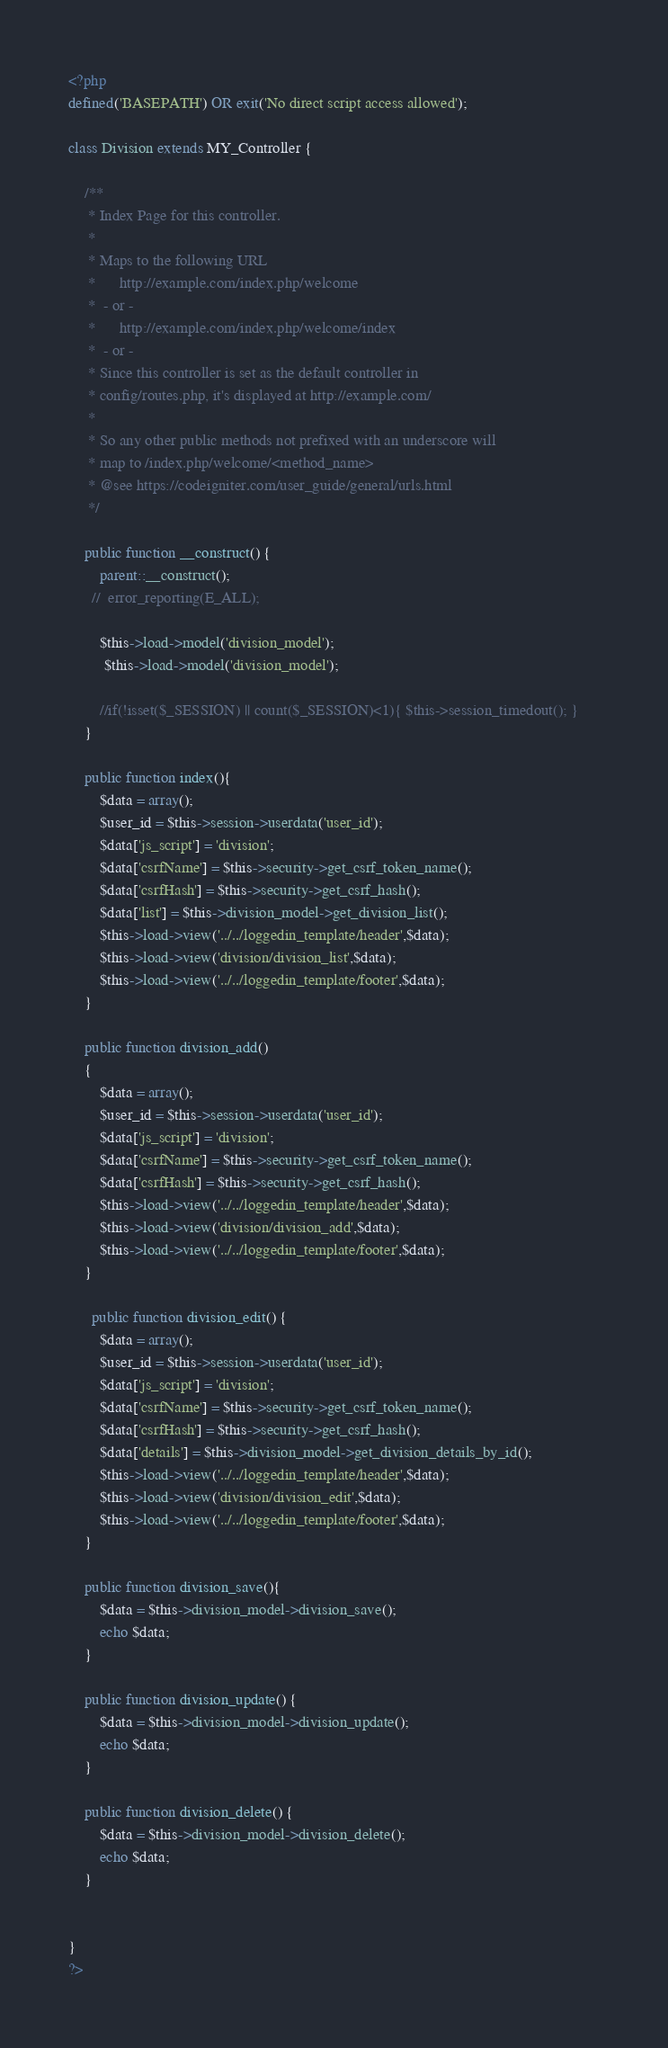Convert code to text. <code><loc_0><loc_0><loc_500><loc_500><_PHP_><?php
defined('BASEPATH') OR exit('No direct script access allowed');

class Division extends MY_Controller {

	/**
	 * Index Page for this controller.
	 *
	 * Maps to the following URL
	 * 		http://example.com/index.php/welcome
	 *	- or -
	 * 		http://example.com/index.php/welcome/index
	 *	- or -
	 * Since this controller is set as the default controller in
	 * config/routes.php, it's displayed at http://example.com/
	 *
	 * So any other public methods not prefixed with an underscore will
	 * map to /index.php/welcome/<method_name>
	 * @see https://codeigniter.com/user_guide/general/urls.html
	 */

    public function __construct() {
        parent::__construct();
      //  error_reporting(E_ALL);
	 
        $this->load->model('division_model');
		 $this->load->model('division_model');
        
        //if(!isset($_SESSION) || count($_SESSION)<1){ $this->session_timedout(); }
    }
	
	public function index(){
		$data = array();
        $user_id = $this->session->userdata('user_id');
        $data['js_script'] = 'division';
        $data['csrfName'] = $this->security->get_csrf_token_name();
        $data['csrfHash'] = $this->security->get_csrf_hash();
        $data['list'] = $this->division_model->get_division_list();
        $this->load->view('../../loggedin_template/header',$data);
        $this->load->view('division/division_list',$data);
        $this->load->view('../../loggedin_template/footer',$data);
	}
	
	public function division_add()
	{
		$data = array();
        $user_id = $this->session->userdata('user_id');
        $data['js_script'] = 'division';
        $data['csrfName'] = $this->security->get_csrf_token_name();
        $data['csrfHash'] = $this->security->get_csrf_hash();	 
        $this->load->view('../../loggedin_template/header',$data);
        $this->load->view('division/division_add',$data);
        $this->load->view('../../loggedin_template/footer',$data);
	}
	
	  public function division_edit() {
        $data = array();
        $user_id = $this->session->userdata('user_id');
        $data['js_script'] = 'division';
        $data['csrfName'] = $this->security->get_csrf_token_name();
        $data['csrfHash'] = $this->security->get_csrf_hash();
        $data['details'] = $this->division_model->get_division_details_by_id();				 
        $this->load->view('../../loggedin_template/header',$data);
        $this->load->view('division/division_edit',$data);
        $this->load->view('../../loggedin_template/footer',$data);
    }
	
	public function division_save(){
		$data = $this->division_model->division_save();
        echo $data;  
	}
	
	public function division_update() {
        $data = $this->division_model->division_update();
        echo $data;
    }
	
	public function division_delete() {
        $data = $this->division_model->division_delete();
        echo $data;
    }
	
	
}
?></code> 